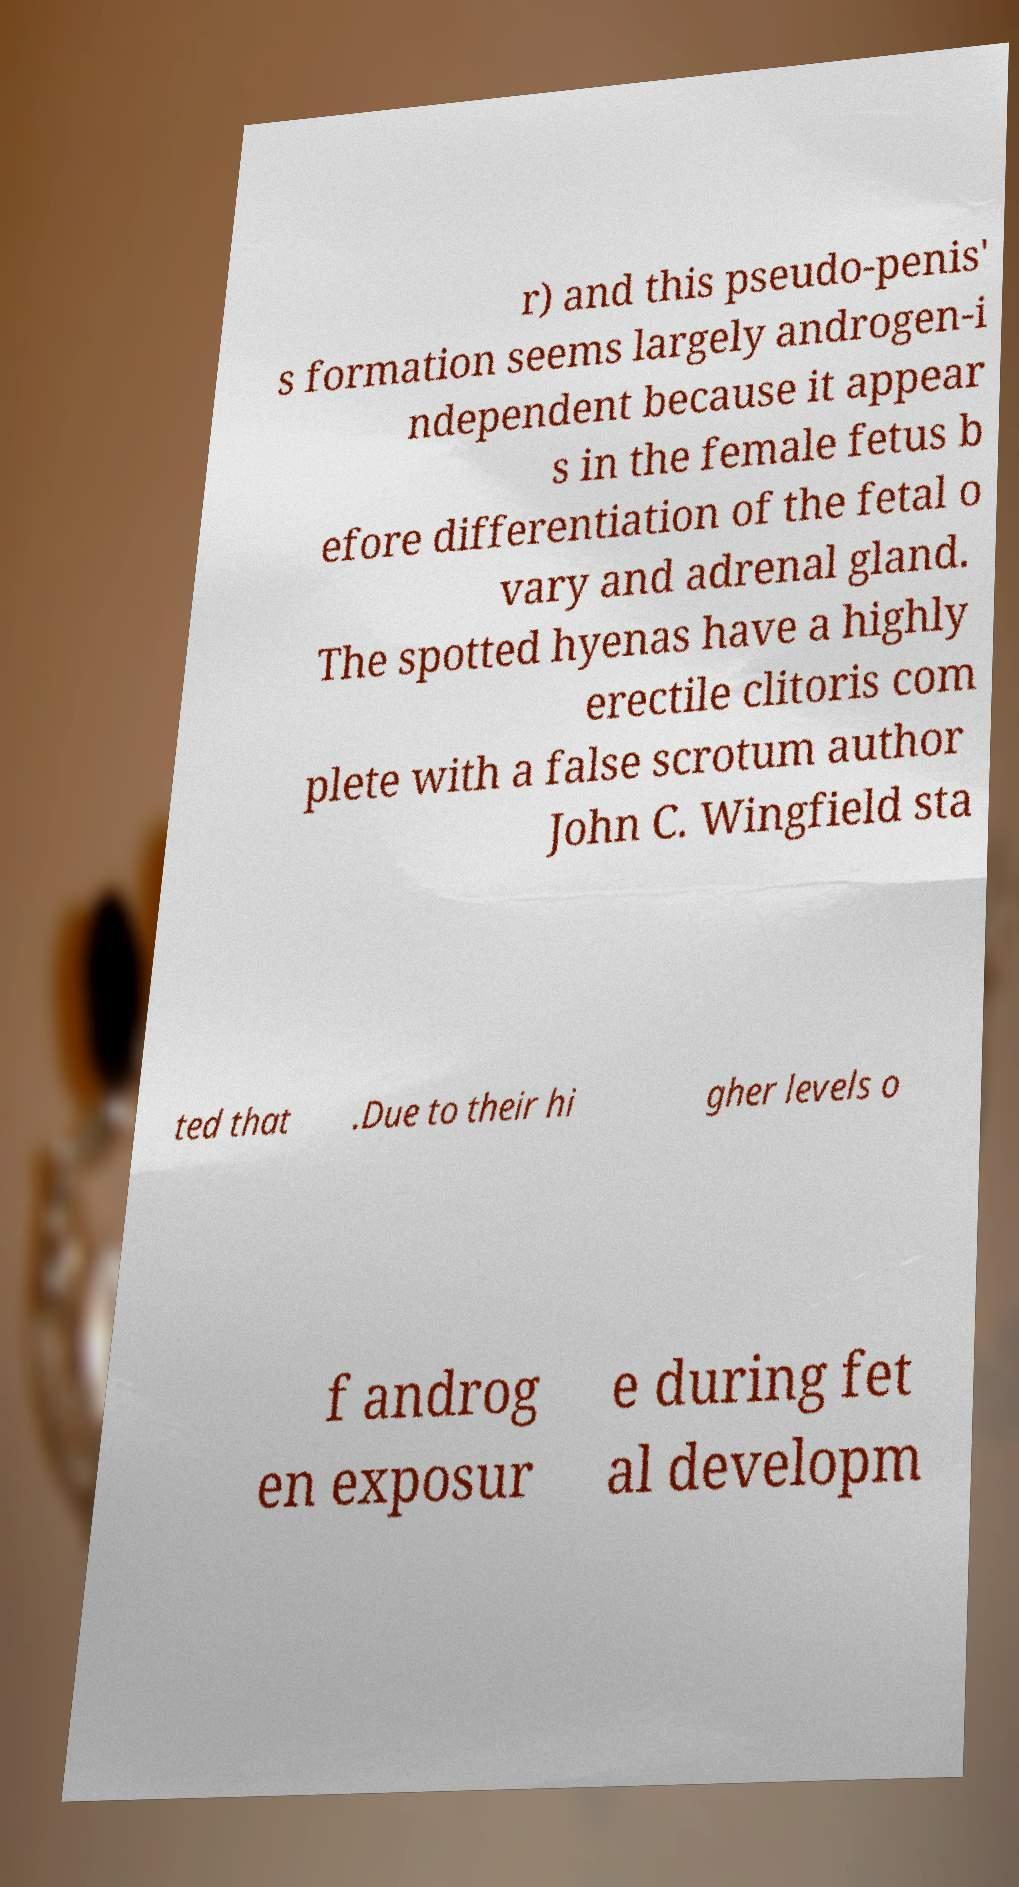Please identify and transcribe the text found in this image. r) and this pseudo-penis' s formation seems largely androgen-i ndependent because it appear s in the female fetus b efore differentiation of the fetal o vary and adrenal gland. The spotted hyenas have a highly erectile clitoris com plete with a false scrotum author John C. Wingfield sta ted that .Due to their hi gher levels o f androg en exposur e during fet al developm 